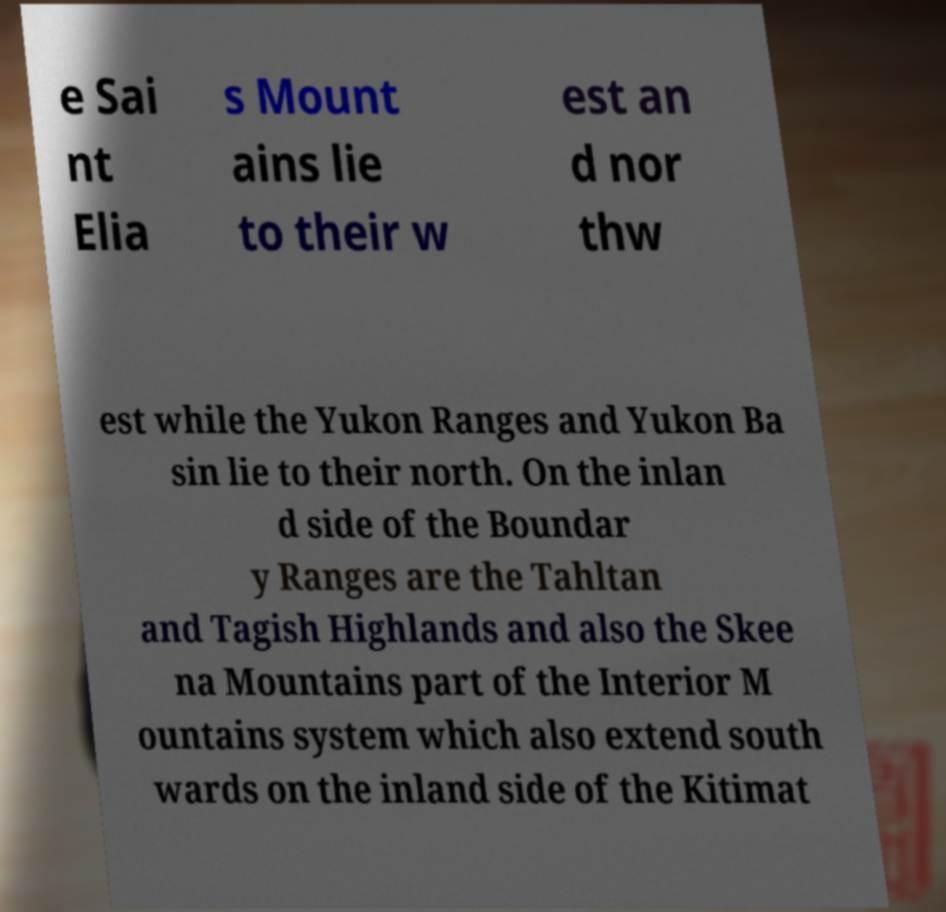What messages or text are displayed in this image? I need them in a readable, typed format. e Sai nt Elia s Mount ains lie to their w est an d nor thw est while the Yukon Ranges and Yukon Ba sin lie to their north. On the inlan d side of the Boundar y Ranges are the Tahltan and Tagish Highlands and also the Skee na Mountains part of the Interior M ountains system which also extend south wards on the inland side of the Kitimat 